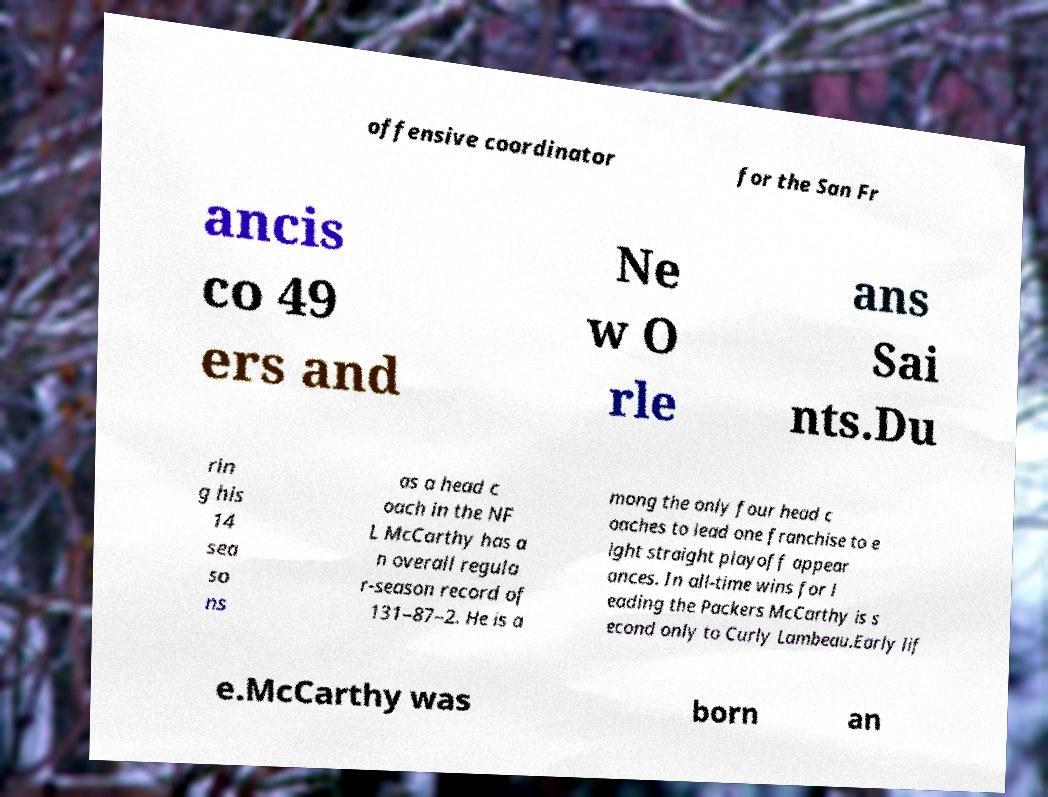Could you assist in decoding the text presented in this image and type it out clearly? offensive coordinator for the San Fr ancis co 49 ers and Ne w O rle ans Sai nts.Du rin g his 14 sea so ns as a head c oach in the NF L McCarthy has a n overall regula r-season record of 131–87–2. He is a mong the only four head c oaches to lead one franchise to e ight straight playoff appear ances. In all-time wins for l eading the Packers McCarthy is s econd only to Curly Lambeau.Early lif e.McCarthy was born an 